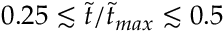Convert formula to latex. <formula><loc_0><loc_0><loc_500><loc_500>0 . 2 5 \lesssim \tilde { t } / \tilde { t } _ { \max } \lesssim 0 . 5</formula> 